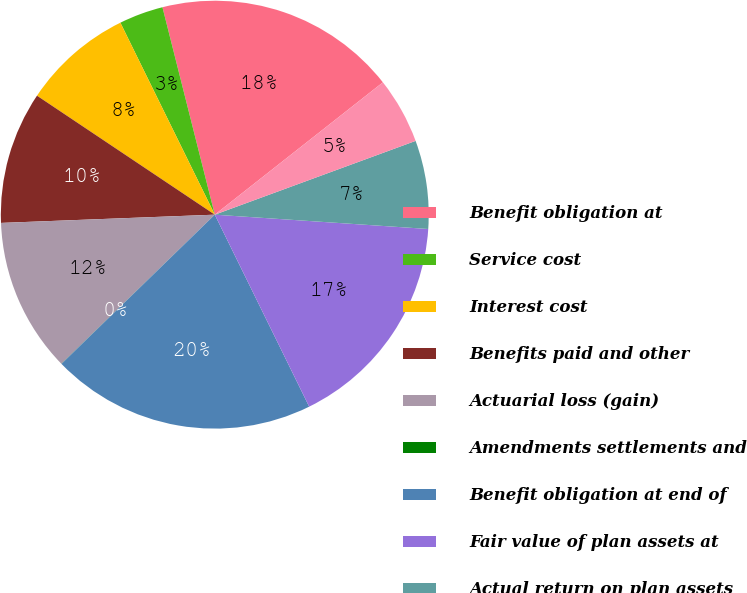<chart> <loc_0><loc_0><loc_500><loc_500><pie_chart><fcel>Benefit obligation at<fcel>Service cost<fcel>Interest cost<fcel>Benefits paid and other<fcel>Actuarial loss (gain)<fcel>Amendments settlements and<fcel>Benefit obligation at end of<fcel>Fair value of plan assets at<fcel>Actual return on plan assets<fcel>Employer contributions<nl><fcel>18.32%<fcel>3.34%<fcel>8.34%<fcel>10.0%<fcel>11.66%<fcel>0.01%<fcel>19.99%<fcel>16.66%<fcel>6.67%<fcel>5.01%<nl></chart> 